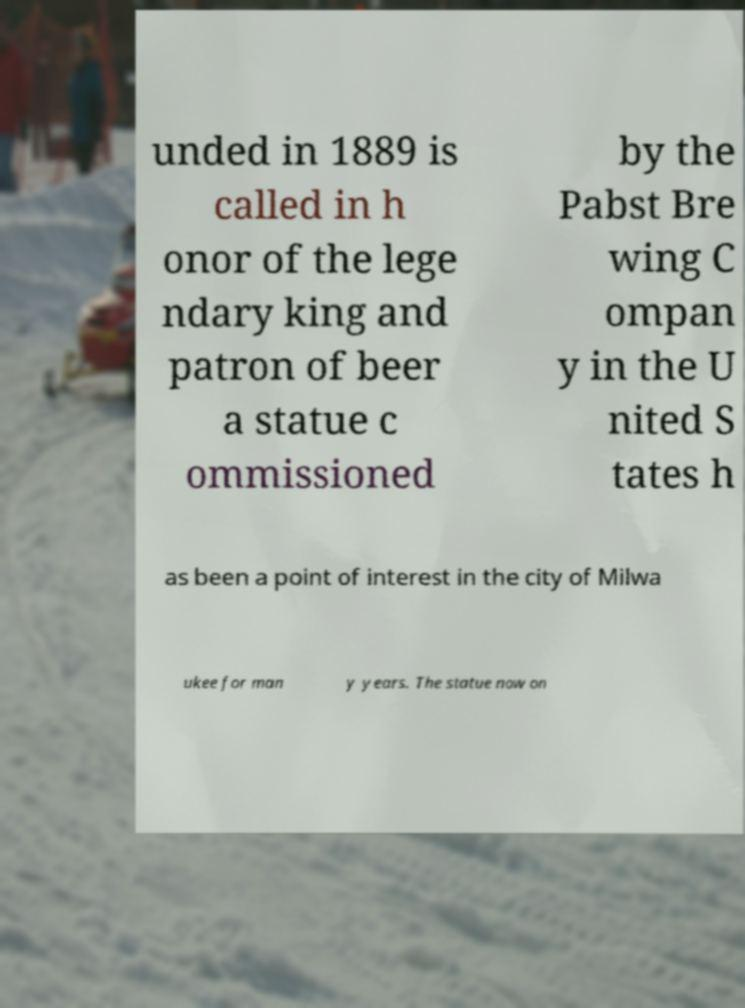Can you read and provide the text displayed in the image?This photo seems to have some interesting text. Can you extract and type it out for me? unded in 1889 is called in h onor of the lege ndary king and patron of beer a statue c ommissioned by the Pabst Bre wing C ompan y in the U nited S tates h as been a point of interest in the city of Milwa ukee for man y years. The statue now on 